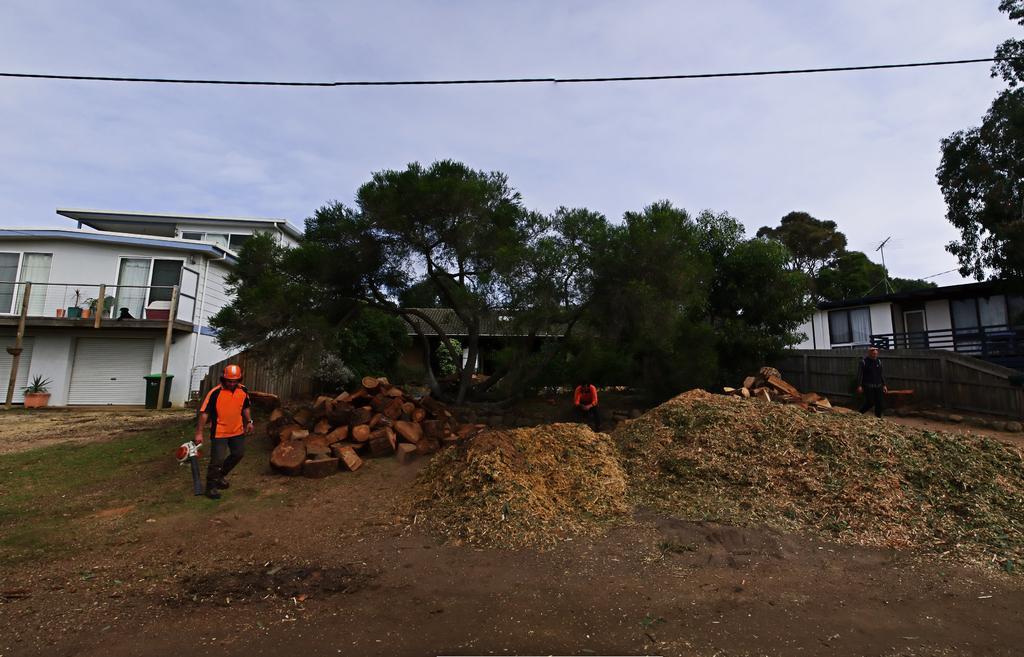How would you summarize this image in a sentence or two? There are two people standing and a person sitting. These are the tree trunks, which are chopped. I can see the trees. These are the houses with glass doors and windows. This looks like a rolling shutter. I can see a flower pot with a plant. This looks like a dustbin. 